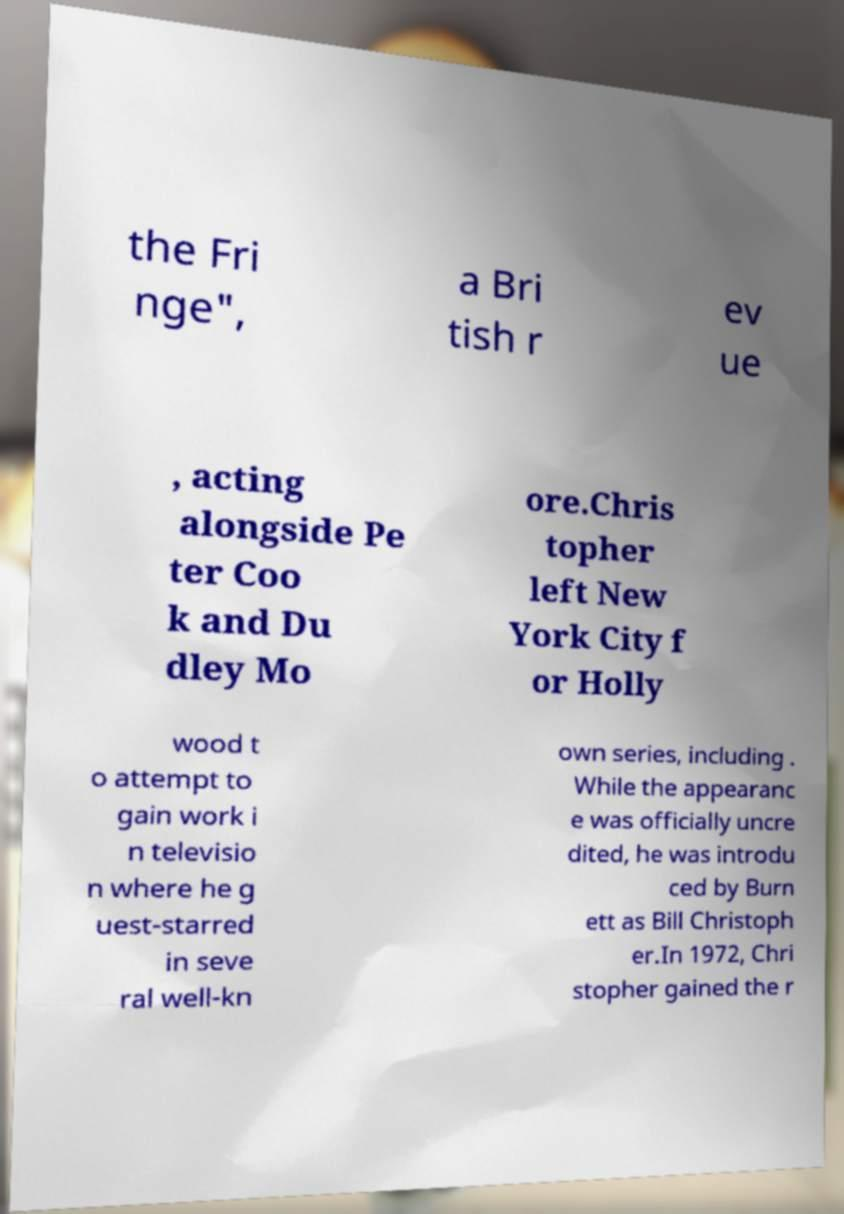Please read and relay the text visible in this image. What does it say? the Fri nge", a Bri tish r ev ue , acting alongside Pe ter Coo k and Du dley Mo ore.Chris topher left New York City f or Holly wood t o attempt to gain work i n televisio n where he g uest-starred in seve ral well-kn own series, including . While the appearanc e was officially uncre dited, he was introdu ced by Burn ett as Bill Christoph er.In 1972, Chri stopher gained the r 